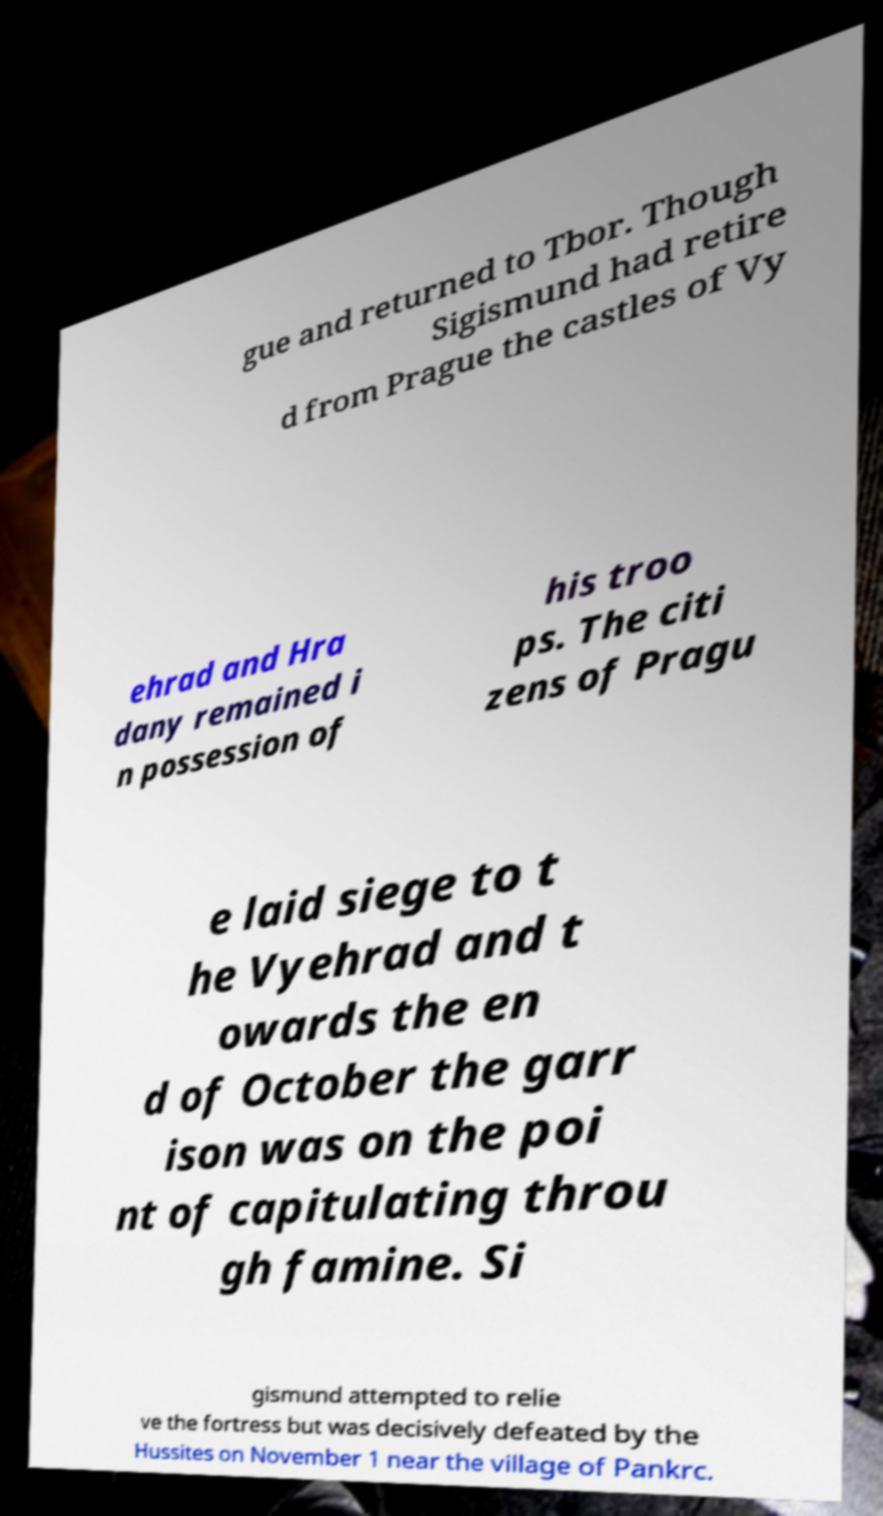For documentation purposes, I need the text within this image transcribed. Could you provide that? gue and returned to Tbor. Though Sigismund had retire d from Prague the castles of Vy ehrad and Hra dany remained i n possession of his troo ps. The citi zens of Pragu e laid siege to t he Vyehrad and t owards the en d of October the garr ison was on the poi nt of capitulating throu gh famine. Si gismund attempted to relie ve the fortress but was decisively defeated by the Hussites on November 1 near the village of Pankrc. 